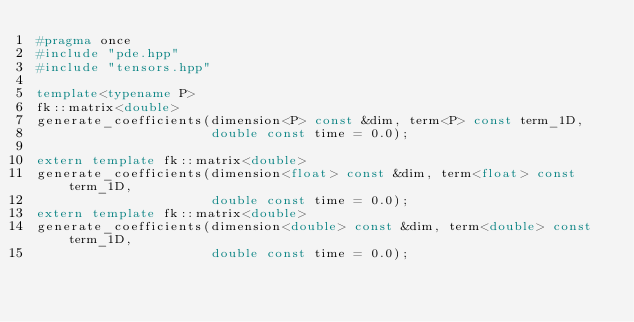Convert code to text. <code><loc_0><loc_0><loc_500><loc_500><_C++_>#pragma once
#include "pde.hpp"
#include "tensors.hpp"

template<typename P>
fk::matrix<double>
generate_coefficients(dimension<P> const &dim, term<P> const term_1D,
                      double const time = 0.0);

extern template fk::matrix<double>
generate_coefficients(dimension<float> const &dim, term<float> const term_1D,
                      double const time = 0.0);
extern template fk::matrix<double>
generate_coefficients(dimension<double> const &dim, term<double> const term_1D,
                      double const time = 0.0);
</code> 